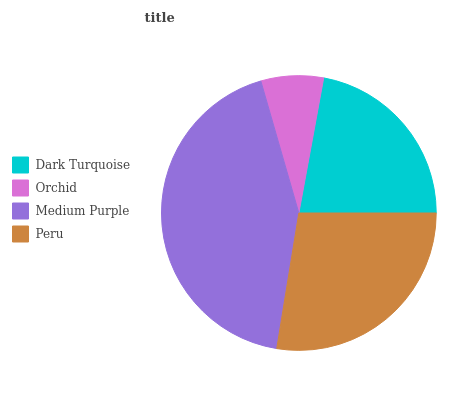Is Orchid the minimum?
Answer yes or no. Yes. Is Medium Purple the maximum?
Answer yes or no. Yes. Is Medium Purple the minimum?
Answer yes or no. No. Is Orchid the maximum?
Answer yes or no. No. Is Medium Purple greater than Orchid?
Answer yes or no. Yes. Is Orchid less than Medium Purple?
Answer yes or no. Yes. Is Orchid greater than Medium Purple?
Answer yes or no. No. Is Medium Purple less than Orchid?
Answer yes or no. No. Is Peru the high median?
Answer yes or no. Yes. Is Dark Turquoise the low median?
Answer yes or no. Yes. Is Dark Turquoise the high median?
Answer yes or no. No. Is Peru the low median?
Answer yes or no. No. 